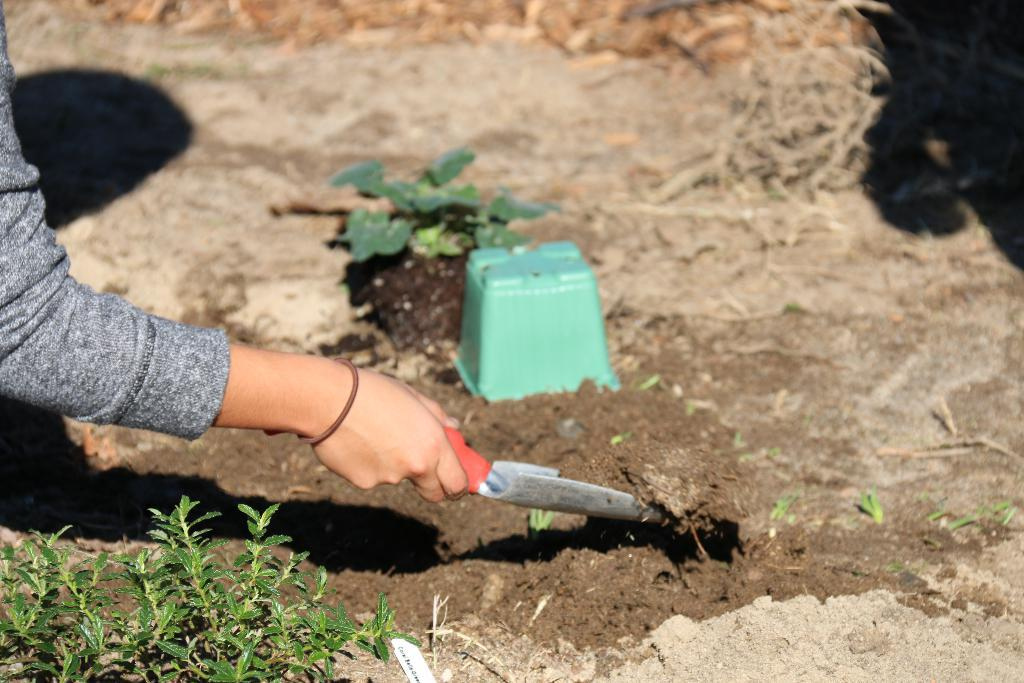What is the person in the image holding? The person is holding a spade in the image. What type of material can be seen in the image? Soil is visible in the image. What type of vegetation is present in the image? There are plants in the image. What is the plants contained in? There is a pot in the image. What is the condition of the plant stems in the image? Dried stems are present in the image. What type of songs can be heard playing in the background of the image? There is no audio or music present in the image, so it is not possible to determine what songs might be heard. 